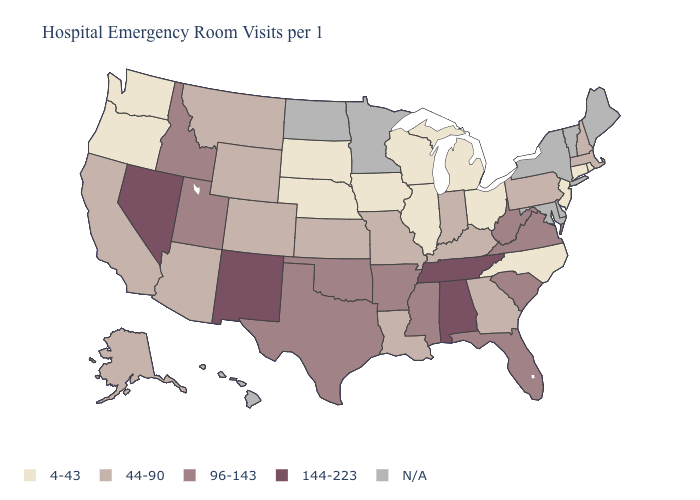What is the highest value in the West ?
Answer briefly. 144-223. Name the states that have a value in the range 144-223?
Short answer required. Alabama, Nevada, New Mexico, Tennessee. What is the value of Delaware?
Give a very brief answer. N/A. Name the states that have a value in the range 96-143?
Quick response, please. Arkansas, Florida, Idaho, Mississippi, Oklahoma, South Carolina, Texas, Utah, Virginia, West Virginia. Which states hav the highest value in the Northeast?
Short answer required. Massachusetts, New Hampshire, Pennsylvania. Name the states that have a value in the range 144-223?
Write a very short answer. Alabama, Nevada, New Mexico, Tennessee. Among the states that border Pennsylvania , which have the lowest value?
Short answer required. New Jersey, Ohio. Does Oregon have the highest value in the USA?
Answer briefly. No. Which states hav the highest value in the South?
Concise answer only. Alabama, Tennessee. Among the states that border New Mexico , does Utah have the lowest value?
Quick response, please. No. Name the states that have a value in the range 144-223?
Give a very brief answer. Alabama, Nevada, New Mexico, Tennessee. Name the states that have a value in the range 96-143?
Be succinct. Arkansas, Florida, Idaho, Mississippi, Oklahoma, South Carolina, Texas, Utah, Virginia, West Virginia. What is the highest value in the USA?
Quick response, please. 144-223. Name the states that have a value in the range N/A?
Short answer required. Delaware, Hawaii, Maine, Maryland, Minnesota, New York, North Dakota, Vermont. 